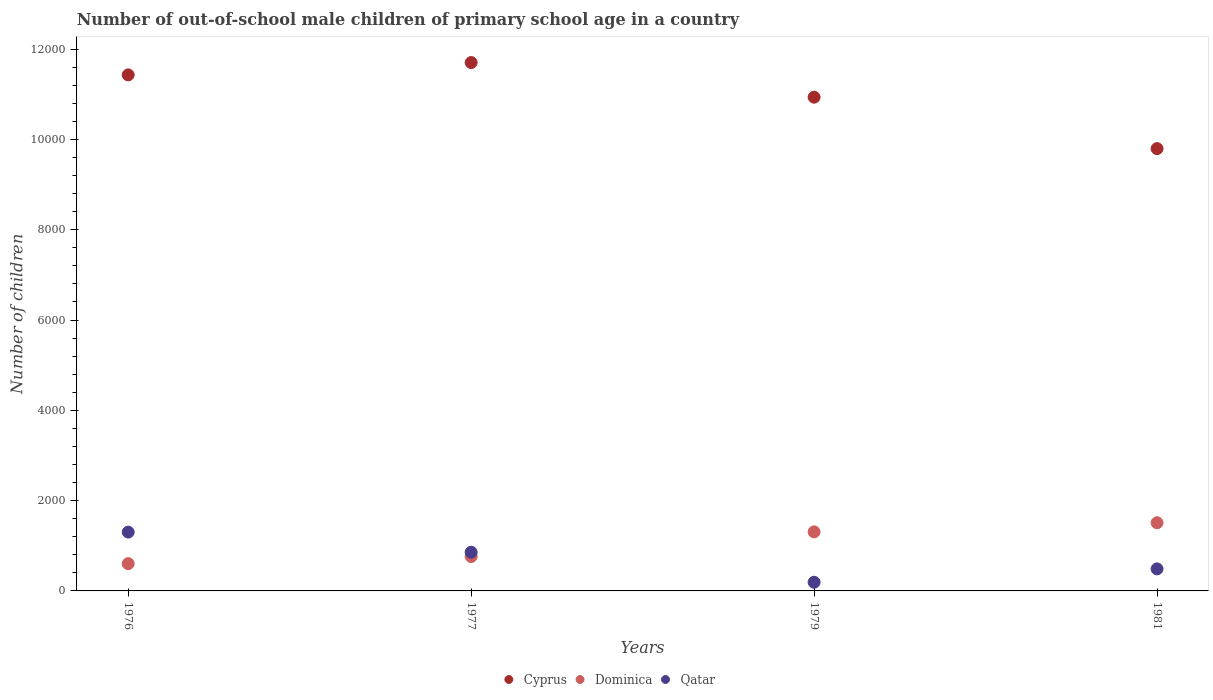How many different coloured dotlines are there?
Ensure brevity in your answer.  3. What is the number of out-of-school male children in Cyprus in 1976?
Give a very brief answer. 1.14e+04. Across all years, what is the maximum number of out-of-school male children in Qatar?
Give a very brief answer. 1303. Across all years, what is the minimum number of out-of-school male children in Dominica?
Your response must be concise. 604. In which year was the number of out-of-school male children in Qatar minimum?
Offer a very short reply. 1979. What is the total number of out-of-school male children in Qatar in the graph?
Provide a short and direct response. 2841. What is the difference between the number of out-of-school male children in Cyprus in 1977 and that in 1981?
Provide a succinct answer. 1906. What is the difference between the number of out-of-school male children in Cyprus in 1981 and the number of out-of-school male children in Dominica in 1976?
Your answer should be very brief. 9193. What is the average number of out-of-school male children in Qatar per year?
Provide a short and direct response. 710.25. In the year 1977, what is the difference between the number of out-of-school male children in Dominica and number of out-of-school male children in Cyprus?
Provide a succinct answer. -1.09e+04. In how many years, is the number of out-of-school male children in Qatar greater than 9200?
Your answer should be compact. 0. What is the ratio of the number of out-of-school male children in Dominica in 1976 to that in 1977?
Your answer should be very brief. 0.79. Is the number of out-of-school male children in Cyprus in 1976 less than that in 1981?
Offer a very short reply. No. What is the difference between the highest and the second highest number of out-of-school male children in Dominica?
Give a very brief answer. 202. What is the difference between the highest and the lowest number of out-of-school male children in Qatar?
Provide a short and direct response. 1111. In how many years, is the number of out-of-school male children in Cyprus greater than the average number of out-of-school male children in Cyprus taken over all years?
Ensure brevity in your answer.  2. Is it the case that in every year, the sum of the number of out-of-school male children in Dominica and number of out-of-school male children in Qatar  is greater than the number of out-of-school male children in Cyprus?
Give a very brief answer. No. Is the number of out-of-school male children in Cyprus strictly less than the number of out-of-school male children in Qatar over the years?
Your response must be concise. No. How many years are there in the graph?
Offer a terse response. 4. Where does the legend appear in the graph?
Provide a short and direct response. Bottom center. How are the legend labels stacked?
Ensure brevity in your answer.  Horizontal. What is the title of the graph?
Make the answer very short. Number of out-of-school male children of primary school age in a country. What is the label or title of the X-axis?
Provide a short and direct response. Years. What is the label or title of the Y-axis?
Offer a terse response. Number of children. What is the Number of children in Cyprus in 1976?
Offer a terse response. 1.14e+04. What is the Number of children of Dominica in 1976?
Your answer should be compact. 604. What is the Number of children in Qatar in 1976?
Keep it short and to the point. 1303. What is the Number of children in Cyprus in 1977?
Your response must be concise. 1.17e+04. What is the Number of children in Dominica in 1977?
Offer a terse response. 762. What is the Number of children of Qatar in 1977?
Offer a very short reply. 858. What is the Number of children in Cyprus in 1979?
Make the answer very short. 1.09e+04. What is the Number of children of Dominica in 1979?
Provide a short and direct response. 1308. What is the Number of children of Qatar in 1979?
Your answer should be very brief. 192. What is the Number of children of Cyprus in 1981?
Offer a very short reply. 9797. What is the Number of children in Dominica in 1981?
Keep it short and to the point. 1510. What is the Number of children of Qatar in 1981?
Your answer should be very brief. 488. Across all years, what is the maximum Number of children of Cyprus?
Ensure brevity in your answer.  1.17e+04. Across all years, what is the maximum Number of children of Dominica?
Your answer should be compact. 1510. Across all years, what is the maximum Number of children of Qatar?
Keep it short and to the point. 1303. Across all years, what is the minimum Number of children of Cyprus?
Give a very brief answer. 9797. Across all years, what is the minimum Number of children of Dominica?
Your answer should be very brief. 604. Across all years, what is the minimum Number of children in Qatar?
Give a very brief answer. 192. What is the total Number of children in Cyprus in the graph?
Your answer should be very brief. 4.39e+04. What is the total Number of children in Dominica in the graph?
Provide a succinct answer. 4184. What is the total Number of children of Qatar in the graph?
Provide a succinct answer. 2841. What is the difference between the Number of children of Cyprus in 1976 and that in 1977?
Give a very brief answer. -273. What is the difference between the Number of children of Dominica in 1976 and that in 1977?
Your response must be concise. -158. What is the difference between the Number of children in Qatar in 1976 and that in 1977?
Provide a succinct answer. 445. What is the difference between the Number of children in Cyprus in 1976 and that in 1979?
Keep it short and to the point. 494. What is the difference between the Number of children of Dominica in 1976 and that in 1979?
Ensure brevity in your answer.  -704. What is the difference between the Number of children in Qatar in 1976 and that in 1979?
Your response must be concise. 1111. What is the difference between the Number of children in Cyprus in 1976 and that in 1981?
Provide a short and direct response. 1633. What is the difference between the Number of children in Dominica in 1976 and that in 1981?
Provide a short and direct response. -906. What is the difference between the Number of children of Qatar in 1976 and that in 1981?
Your answer should be compact. 815. What is the difference between the Number of children in Cyprus in 1977 and that in 1979?
Keep it short and to the point. 767. What is the difference between the Number of children of Dominica in 1977 and that in 1979?
Make the answer very short. -546. What is the difference between the Number of children in Qatar in 1977 and that in 1979?
Make the answer very short. 666. What is the difference between the Number of children in Cyprus in 1977 and that in 1981?
Provide a short and direct response. 1906. What is the difference between the Number of children in Dominica in 1977 and that in 1981?
Your response must be concise. -748. What is the difference between the Number of children in Qatar in 1977 and that in 1981?
Make the answer very short. 370. What is the difference between the Number of children in Cyprus in 1979 and that in 1981?
Make the answer very short. 1139. What is the difference between the Number of children of Dominica in 1979 and that in 1981?
Your response must be concise. -202. What is the difference between the Number of children of Qatar in 1979 and that in 1981?
Make the answer very short. -296. What is the difference between the Number of children of Cyprus in 1976 and the Number of children of Dominica in 1977?
Offer a very short reply. 1.07e+04. What is the difference between the Number of children of Cyprus in 1976 and the Number of children of Qatar in 1977?
Your answer should be compact. 1.06e+04. What is the difference between the Number of children in Dominica in 1976 and the Number of children in Qatar in 1977?
Offer a very short reply. -254. What is the difference between the Number of children in Cyprus in 1976 and the Number of children in Dominica in 1979?
Your answer should be compact. 1.01e+04. What is the difference between the Number of children of Cyprus in 1976 and the Number of children of Qatar in 1979?
Your answer should be very brief. 1.12e+04. What is the difference between the Number of children in Dominica in 1976 and the Number of children in Qatar in 1979?
Make the answer very short. 412. What is the difference between the Number of children in Cyprus in 1976 and the Number of children in Dominica in 1981?
Your answer should be very brief. 9920. What is the difference between the Number of children of Cyprus in 1976 and the Number of children of Qatar in 1981?
Provide a succinct answer. 1.09e+04. What is the difference between the Number of children in Dominica in 1976 and the Number of children in Qatar in 1981?
Give a very brief answer. 116. What is the difference between the Number of children in Cyprus in 1977 and the Number of children in Dominica in 1979?
Make the answer very short. 1.04e+04. What is the difference between the Number of children of Cyprus in 1977 and the Number of children of Qatar in 1979?
Your answer should be compact. 1.15e+04. What is the difference between the Number of children in Dominica in 1977 and the Number of children in Qatar in 1979?
Your answer should be very brief. 570. What is the difference between the Number of children of Cyprus in 1977 and the Number of children of Dominica in 1981?
Keep it short and to the point. 1.02e+04. What is the difference between the Number of children in Cyprus in 1977 and the Number of children in Qatar in 1981?
Give a very brief answer. 1.12e+04. What is the difference between the Number of children in Dominica in 1977 and the Number of children in Qatar in 1981?
Provide a succinct answer. 274. What is the difference between the Number of children of Cyprus in 1979 and the Number of children of Dominica in 1981?
Give a very brief answer. 9426. What is the difference between the Number of children of Cyprus in 1979 and the Number of children of Qatar in 1981?
Offer a terse response. 1.04e+04. What is the difference between the Number of children of Dominica in 1979 and the Number of children of Qatar in 1981?
Your answer should be very brief. 820. What is the average Number of children in Cyprus per year?
Give a very brief answer. 1.10e+04. What is the average Number of children of Dominica per year?
Your answer should be very brief. 1046. What is the average Number of children of Qatar per year?
Offer a terse response. 710.25. In the year 1976, what is the difference between the Number of children in Cyprus and Number of children in Dominica?
Your answer should be compact. 1.08e+04. In the year 1976, what is the difference between the Number of children of Cyprus and Number of children of Qatar?
Your response must be concise. 1.01e+04. In the year 1976, what is the difference between the Number of children of Dominica and Number of children of Qatar?
Make the answer very short. -699. In the year 1977, what is the difference between the Number of children in Cyprus and Number of children in Dominica?
Ensure brevity in your answer.  1.09e+04. In the year 1977, what is the difference between the Number of children in Cyprus and Number of children in Qatar?
Offer a very short reply. 1.08e+04. In the year 1977, what is the difference between the Number of children in Dominica and Number of children in Qatar?
Offer a very short reply. -96. In the year 1979, what is the difference between the Number of children of Cyprus and Number of children of Dominica?
Ensure brevity in your answer.  9628. In the year 1979, what is the difference between the Number of children of Cyprus and Number of children of Qatar?
Keep it short and to the point. 1.07e+04. In the year 1979, what is the difference between the Number of children of Dominica and Number of children of Qatar?
Offer a terse response. 1116. In the year 1981, what is the difference between the Number of children in Cyprus and Number of children in Dominica?
Your answer should be very brief. 8287. In the year 1981, what is the difference between the Number of children of Cyprus and Number of children of Qatar?
Your response must be concise. 9309. In the year 1981, what is the difference between the Number of children in Dominica and Number of children in Qatar?
Make the answer very short. 1022. What is the ratio of the Number of children in Cyprus in 1976 to that in 1977?
Offer a very short reply. 0.98. What is the ratio of the Number of children of Dominica in 1976 to that in 1977?
Provide a succinct answer. 0.79. What is the ratio of the Number of children of Qatar in 1976 to that in 1977?
Your answer should be very brief. 1.52. What is the ratio of the Number of children in Cyprus in 1976 to that in 1979?
Offer a terse response. 1.05. What is the ratio of the Number of children in Dominica in 1976 to that in 1979?
Ensure brevity in your answer.  0.46. What is the ratio of the Number of children in Qatar in 1976 to that in 1979?
Make the answer very short. 6.79. What is the ratio of the Number of children of Cyprus in 1976 to that in 1981?
Your answer should be compact. 1.17. What is the ratio of the Number of children of Qatar in 1976 to that in 1981?
Make the answer very short. 2.67. What is the ratio of the Number of children of Cyprus in 1977 to that in 1979?
Offer a very short reply. 1.07. What is the ratio of the Number of children in Dominica in 1977 to that in 1979?
Give a very brief answer. 0.58. What is the ratio of the Number of children of Qatar in 1977 to that in 1979?
Provide a succinct answer. 4.47. What is the ratio of the Number of children in Cyprus in 1977 to that in 1981?
Give a very brief answer. 1.19. What is the ratio of the Number of children of Dominica in 1977 to that in 1981?
Provide a short and direct response. 0.5. What is the ratio of the Number of children of Qatar in 1977 to that in 1981?
Provide a short and direct response. 1.76. What is the ratio of the Number of children in Cyprus in 1979 to that in 1981?
Keep it short and to the point. 1.12. What is the ratio of the Number of children in Dominica in 1979 to that in 1981?
Provide a succinct answer. 0.87. What is the ratio of the Number of children in Qatar in 1979 to that in 1981?
Offer a terse response. 0.39. What is the difference between the highest and the second highest Number of children in Cyprus?
Offer a terse response. 273. What is the difference between the highest and the second highest Number of children in Dominica?
Give a very brief answer. 202. What is the difference between the highest and the second highest Number of children in Qatar?
Offer a terse response. 445. What is the difference between the highest and the lowest Number of children in Cyprus?
Your answer should be compact. 1906. What is the difference between the highest and the lowest Number of children of Dominica?
Offer a very short reply. 906. What is the difference between the highest and the lowest Number of children of Qatar?
Ensure brevity in your answer.  1111. 